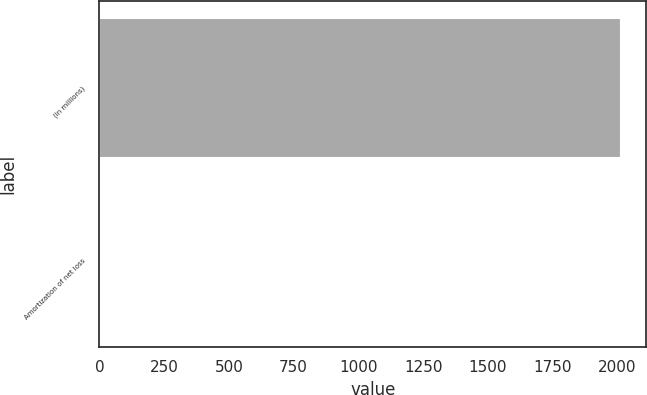<chart> <loc_0><loc_0><loc_500><loc_500><bar_chart><fcel>(in millions)<fcel>Amortization of net loss<nl><fcel>2011<fcel>2<nl></chart> 